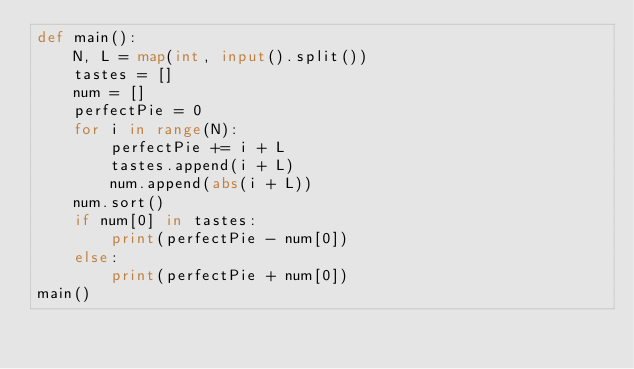<code> <loc_0><loc_0><loc_500><loc_500><_Python_>def main():
    N, L = map(int, input().split())
    tastes = []
    num = []
    perfectPie = 0
    for i in range(N):
        perfectPie += i + L
        tastes.append(i + L)
        num.append(abs(i + L))
    num.sort()
    if num[0] in tastes:
        print(perfectPie - num[0])
    else:
        print(perfectPie + num[0])
main()  </code> 